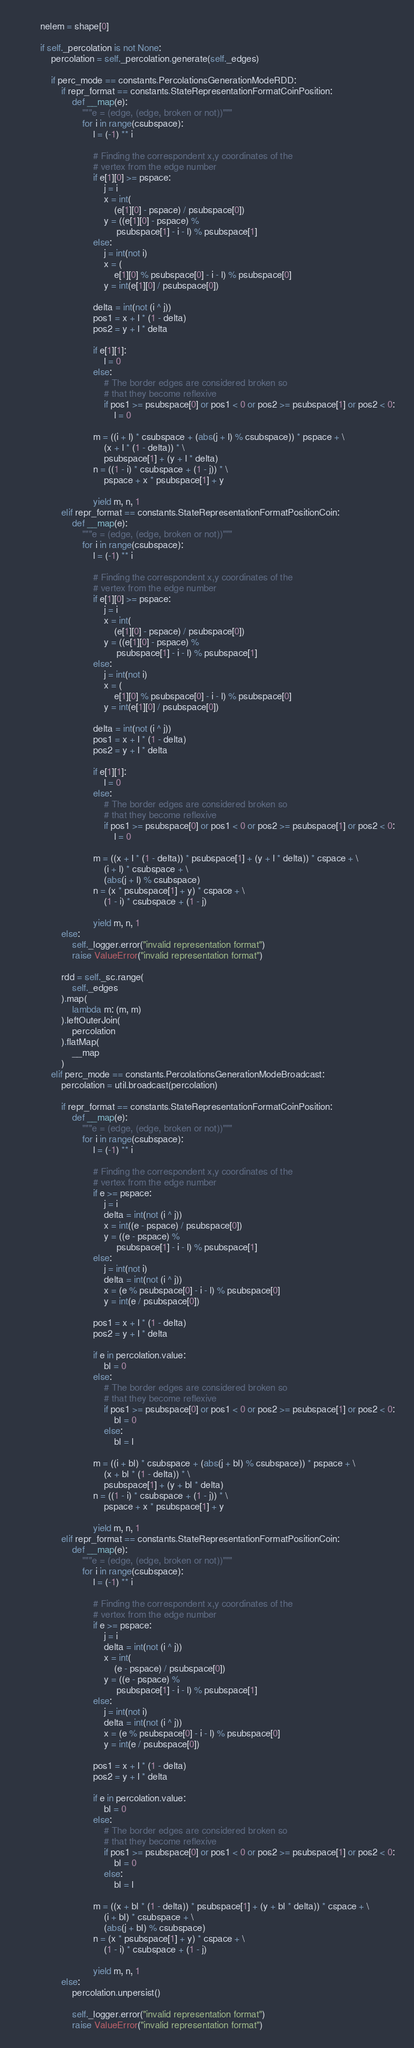Convert code to text. <code><loc_0><loc_0><loc_500><loc_500><_Python_>        nelem = shape[0]

        if self._percolation is not None:
            percolation = self._percolation.generate(self._edges)

            if perc_mode == constants.PercolationsGenerationModeRDD:
                if repr_format == constants.StateRepresentationFormatCoinPosition:
                    def __map(e):
                        """e = (edge, (edge, broken or not))"""
                        for i in range(csubspace):
                            l = (-1) ** i

                            # Finding the correspondent x,y coordinates of the
                            # vertex from the edge number
                            if e[1][0] >= pspace:
                                j = i
                                x = int(
                                    (e[1][0] - pspace) / psubspace[0])
                                y = ((e[1][0] - pspace) %
                                     psubspace[1] - i - l) % psubspace[1]
                            else:
                                j = int(not i)
                                x = (
                                    e[1][0] % psubspace[0] - i - l) % psubspace[0]
                                y = int(e[1][0] / psubspace[0])

                            delta = int(not (i ^ j))
                            pos1 = x + l * (1 - delta)
                            pos2 = y + l * delta

                            if e[1][1]:
                                l = 0
                            else:
                                # The border edges are considered broken so
                                # that they become reflexive
                                if pos1 >= psubspace[0] or pos1 < 0 or pos2 >= psubspace[1] or pos2 < 0:
                                    l = 0

                            m = ((i + l) * csubspace + (abs(j + l) % csubspace)) * pspace + \
                                (x + l * (1 - delta)) * \
                                psubspace[1] + (y + l * delta)
                            n = ((1 - i) * csubspace + (1 - j)) * \
                                pspace + x * psubspace[1] + y

                            yield m, n, 1
                elif repr_format == constants.StateRepresentationFormatPositionCoin:
                    def __map(e):
                        """e = (edge, (edge, broken or not))"""
                        for i in range(csubspace):
                            l = (-1) ** i

                            # Finding the correspondent x,y coordinates of the
                            # vertex from the edge number
                            if e[1][0] >= pspace:
                                j = i
                                x = int(
                                    (e[1][0] - pspace) / psubspace[0])
                                y = ((e[1][0] - pspace) %
                                     psubspace[1] - i - l) % psubspace[1]
                            else:
                                j = int(not i)
                                x = (
                                    e[1][0] % psubspace[0] - i - l) % psubspace[0]
                                y = int(e[1][0] / psubspace[0])

                            delta = int(not (i ^ j))
                            pos1 = x + l * (1 - delta)
                            pos2 = y + l * delta

                            if e[1][1]:
                                l = 0
                            else:
                                # The border edges are considered broken so
                                # that they become reflexive
                                if pos1 >= psubspace[0] or pos1 < 0 or pos2 >= psubspace[1] or pos2 < 0:
                                    l = 0

                            m = ((x + l * (1 - delta)) * psubspace[1] + (y + l * delta)) * cspace + \
                                (i + l) * csubspace + \
                                (abs(j + l) % csubspace)
                            n = (x * psubspace[1] + y) * cspace + \
                                (1 - i) * csubspace + (1 - j)

                            yield m, n, 1
                else:
                    self._logger.error("invalid representation format")
                    raise ValueError("invalid representation format")

                rdd = self._sc.range(
                    self._edges
                ).map(
                    lambda m: (m, m)
                ).leftOuterJoin(
                    percolation
                ).flatMap(
                    __map
                )
            elif perc_mode == constants.PercolationsGenerationModeBroadcast:
                percolation = util.broadcast(percolation)

                if repr_format == constants.StateRepresentationFormatCoinPosition:
                    def __map(e):
                        """e = (edge, (edge, broken or not))"""
                        for i in range(csubspace):
                            l = (-1) ** i

                            # Finding the correspondent x,y coordinates of the
                            # vertex from the edge number
                            if e >= pspace:
                                j = i
                                delta = int(not (i ^ j))
                                x = int((e - pspace) / psubspace[0])
                                y = ((e - pspace) %
                                     psubspace[1] - i - l) % psubspace[1]
                            else:
                                j = int(not i)
                                delta = int(not (i ^ j))
                                x = (e % psubspace[0] - i - l) % psubspace[0]
                                y = int(e / psubspace[0])

                            pos1 = x + l * (1 - delta)
                            pos2 = y + l * delta

                            if e in percolation.value:
                                bl = 0
                            else:
                                # The border edges are considered broken so
                                # that they become reflexive
                                if pos1 >= psubspace[0] or pos1 < 0 or pos2 >= psubspace[1] or pos2 < 0:
                                    bl = 0
                                else:
                                    bl = l

                            m = ((i + bl) * csubspace + (abs(j + bl) % csubspace)) * pspace + \
                                (x + bl * (1 - delta)) * \
                                psubspace[1] + (y + bl * delta)
                            n = ((1 - i) * csubspace + (1 - j)) * \
                                pspace + x * psubspace[1] + y

                            yield m, n, 1
                elif repr_format == constants.StateRepresentationFormatPositionCoin:
                    def __map(e):
                        """e = (edge, (edge, broken or not))"""
                        for i in range(csubspace):
                            l = (-1) ** i

                            # Finding the correspondent x,y coordinates of the
                            # vertex from the edge number
                            if e >= pspace:
                                j = i
                                delta = int(not (i ^ j))
                                x = int(
                                    (e - pspace) / psubspace[0])
                                y = ((e - pspace) %
                                     psubspace[1] - i - l) % psubspace[1]
                            else:
                                j = int(not i)
                                delta = int(not (i ^ j))
                                x = (e % psubspace[0] - i - l) % psubspace[0]
                                y = int(e / psubspace[0])

                            pos1 = x + l * (1 - delta)
                            pos2 = y + l * delta

                            if e in percolation.value:
                                bl = 0
                            else:
                                # The border edges are considered broken so
                                # that they become reflexive
                                if pos1 >= psubspace[0] or pos1 < 0 or pos2 >= psubspace[1] or pos2 < 0:
                                    bl = 0
                                else:
                                    bl = l

                            m = ((x + bl * (1 - delta)) * psubspace[1] + (y + bl * delta)) * cspace + \
                                (i + bl) * csubspace + \
                                (abs(j + bl) % csubspace)
                            n = (x * psubspace[1] + y) * cspace + \
                                (1 - i) * csubspace + (1 - j)

                            yield m, n, 1
                else:
                    percolation.unpersist()

                    self._logger.error("invalid representation format")
                    raise ValueError("invalid representation format")
</code> 